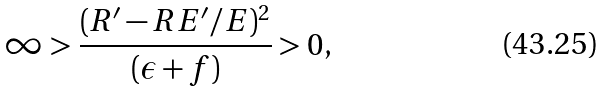<formula> <loc_0><loc_0><loc_500><loc_500>\infty > \frac { ( R ^ { \prime } - R E ^ { \prime } / E ) ^ { 2 } } { ( \epsilon + f ) } > 0 ,</formula> 